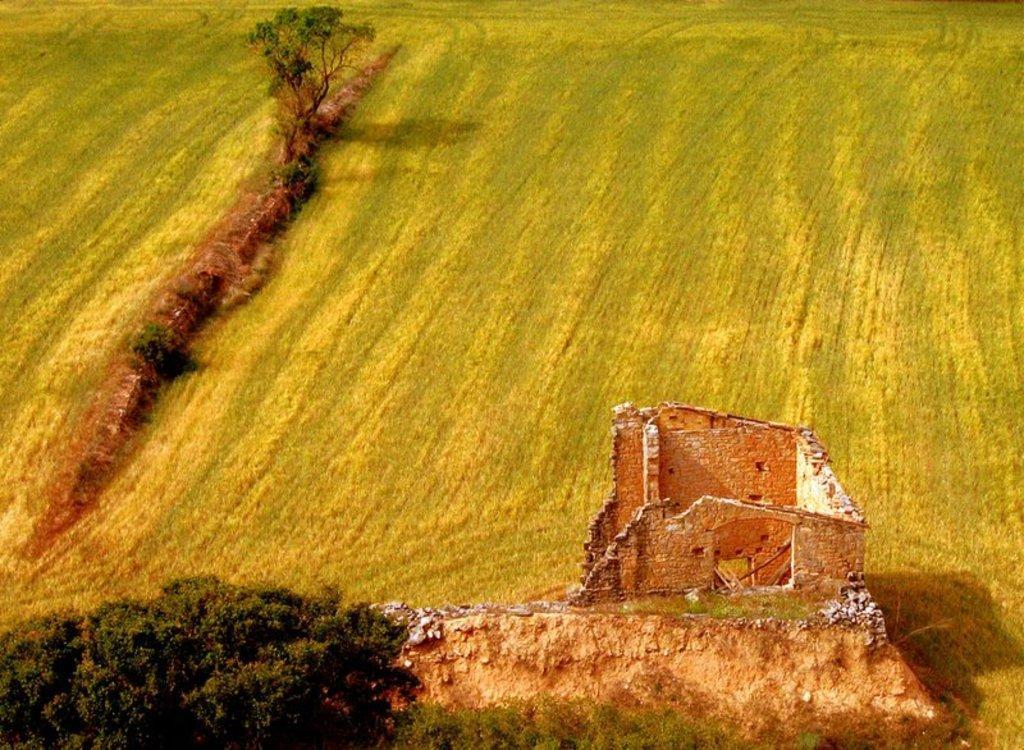Describe this image in one or two sentences. In this picture there is a broken wall at the bottom side of the image and there is greenery around the area of the image. 